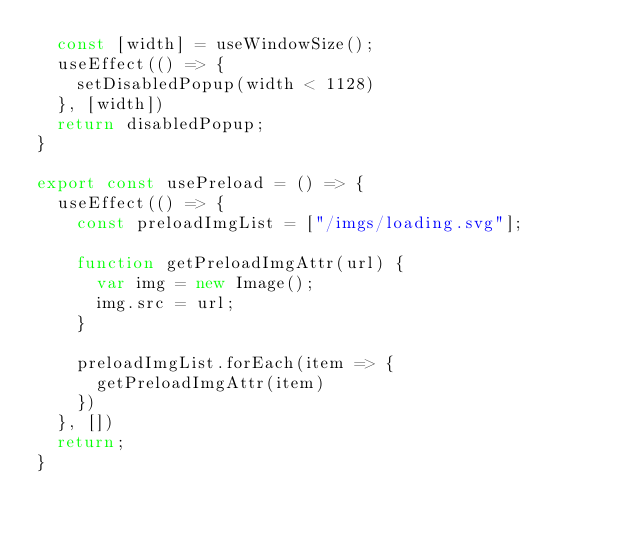Convert code to text. <code><loc_0><loc_0><loc_500><loc_500><_JavaScript_>  const [width] = useWindowSize();
  useEffect(() => {
    setDisabledPopup(width < 1128)
  }, [width])
  return disabledPopup;
}

export const usePreload = () => {
  useEffect(() => {
    const preloadImgList = ["/imgs/loading.svg"];

    function getPreloadImgAttr(url) {
      var img = new Image();
      img.src = url;
    }

    preloadImgList.forEach(item => {
      getPreloadImgAttr(item)
    })
  }, [])
  return;
}
</code> 